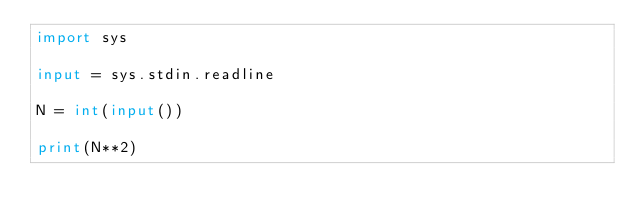Convert code to text. <code><loc_0><loc_0><loc_500><loc_500><_Python_>import sys

input = sys.stdin.readline

N = int(input())

print(N**2)</code> 